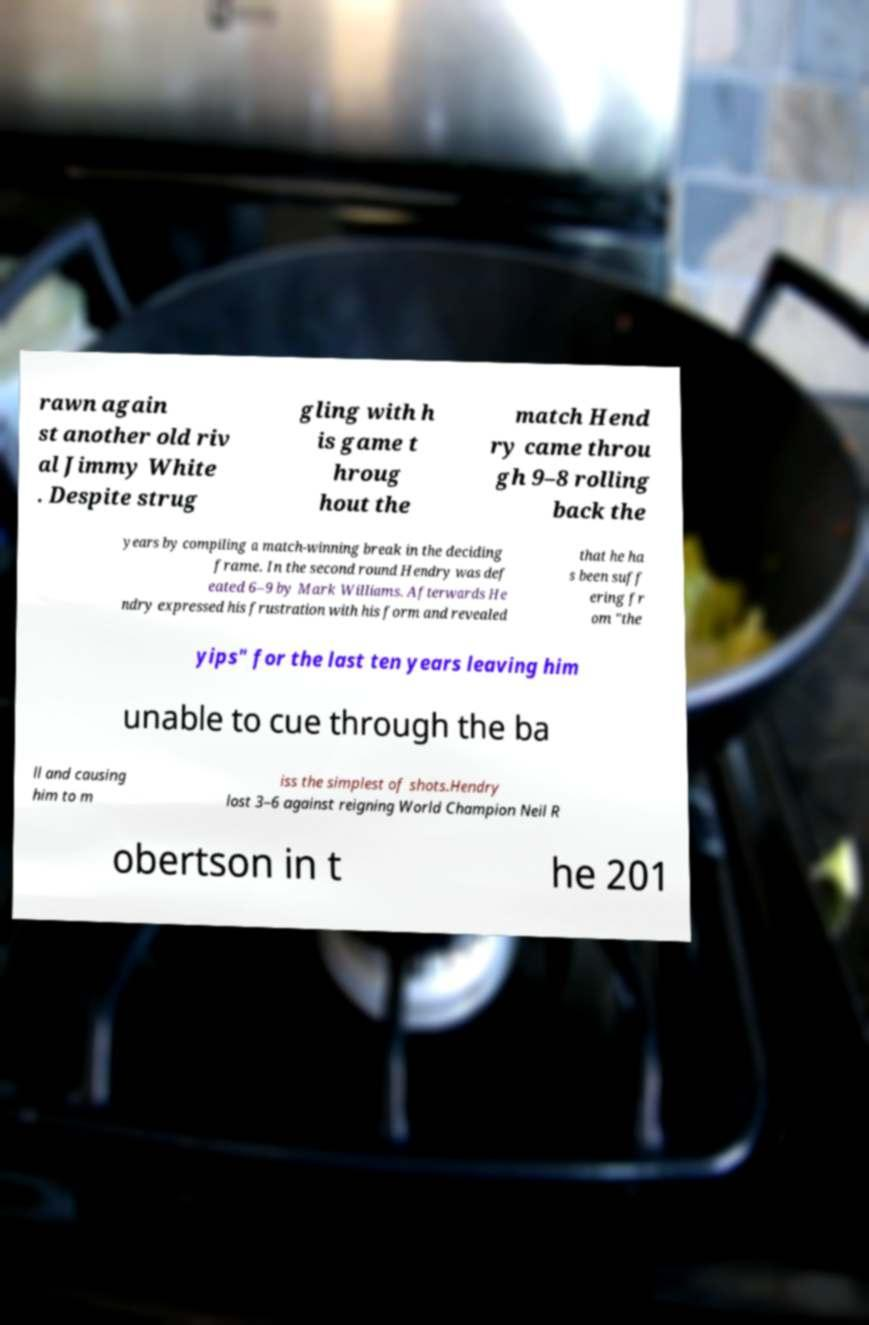Can you read and provide the text displayed in the image?This photo seems to have some interesting text. Can you extract and type it out for me? rawn again st another old riv al Jimmy White . Despite strug gling with h is game t hroug hout the match Hend ry came throu gh 9–8 rolling back the years by compiling a match-winning break in the deciding frame. In the second round Hendry was def eated 6–9 by Mark Williams. Afterwards He ndry expressed his frustration with his form and revealed that he ha s been suff ering fr om "the yips" for the last ten years leaving him unable to cue through the ba ll and causing him to m iss the simplest of shots.Hendry lost 3–6 against reigning World Champion Neil R obertson in t he 201 